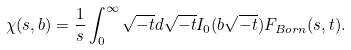Convert formula to latex. <formula><loc_0><loc_0><loc_500><loc_500>\chi ( s , b ) = \frac { 1 } { s } \int _ { 0 } ^ { \infty } \sqrt { - t } d \sqrt { - t } I _ { 0 } ( b \sqrt { - t } ) F _ { B o r n } ( s , t ) .</formula> 